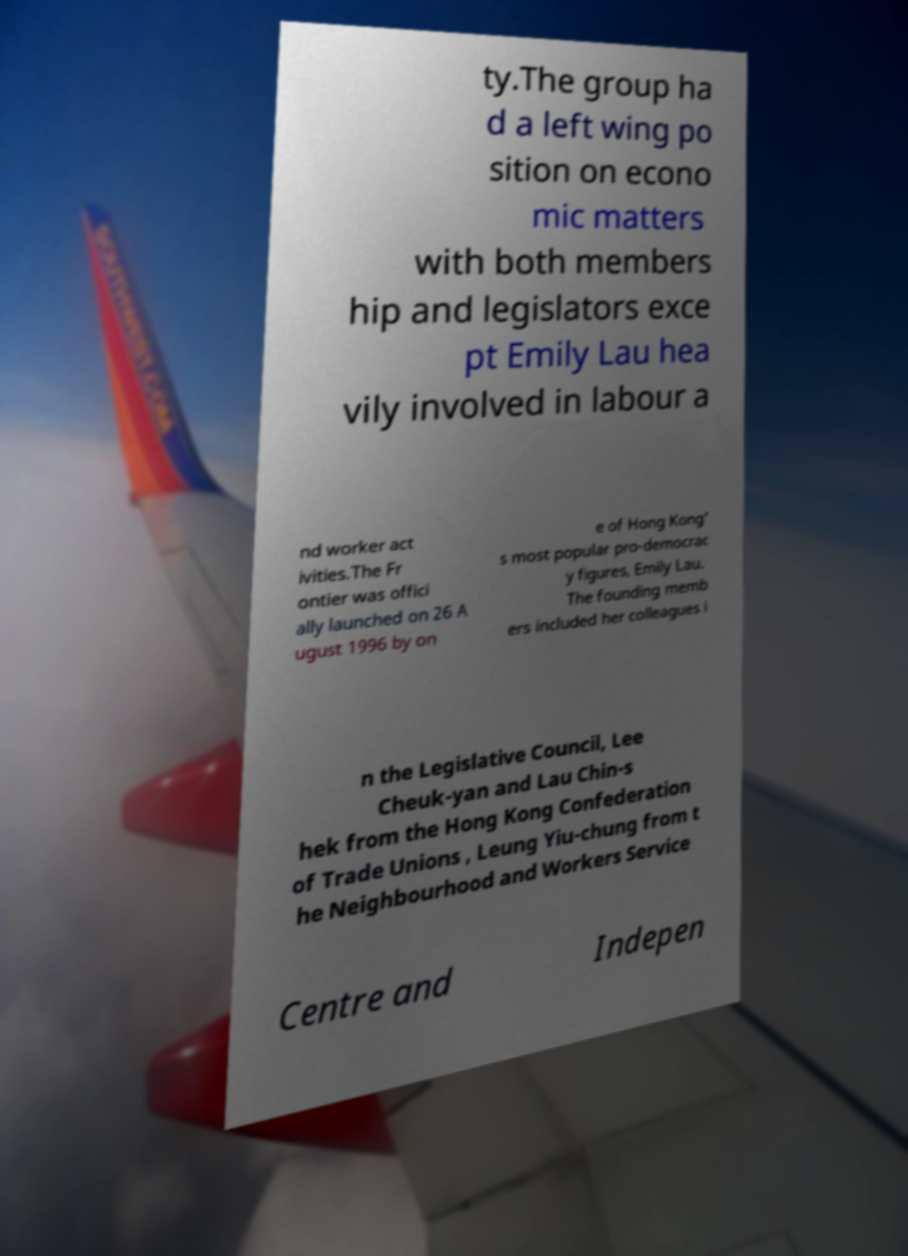Please read and relay the text visible in this image. What does it say? ty.The group ha d a left wing po sition on econo mic matters with both members hip and legislators exce pt Emily Lau hea vily involved in labour a nd worker act ivities.The Fr ontier was offici ally launched on 26 A ugust 1996 by on e of Hong Kong' s most popular pro-democrac y figures, Emily Lau. The founding memb ers included her colleagues i n the Legislative Council, Lee Cheuk-yan and Lau Chin-s hek from the Hong Kong Confederation of Trade Unions , Leung Yiu-chung from t he Neighbourhood and Workers Service Centre and Indepen 